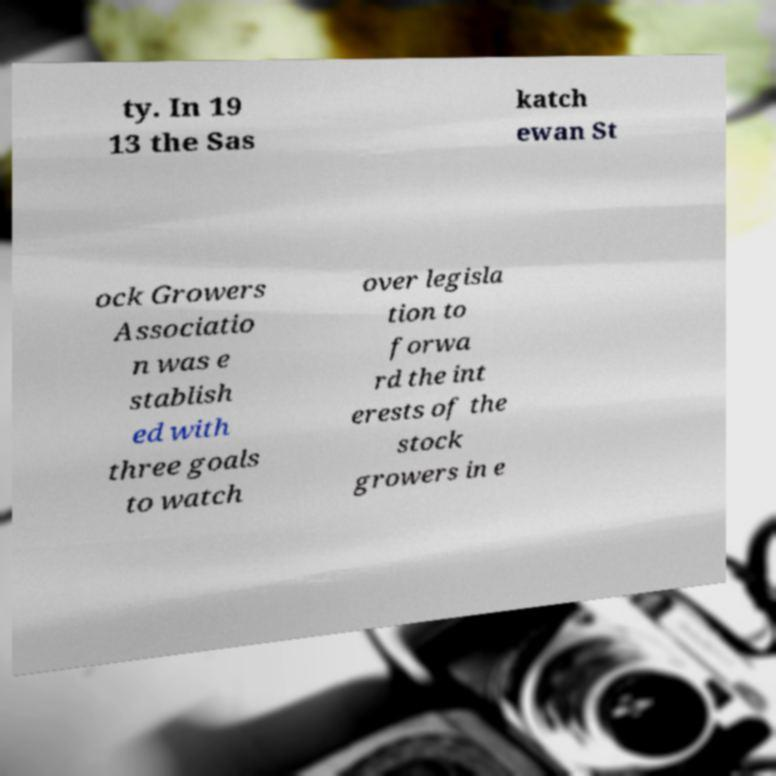Please read and relay the text visible in this image. What does it say? ty. In 19 13 the Sas katch ewan St ock Growers Associatio n was e stablish ed with three goals to watch over legisla tion to forwa rd the int erests of the stock growers in e 